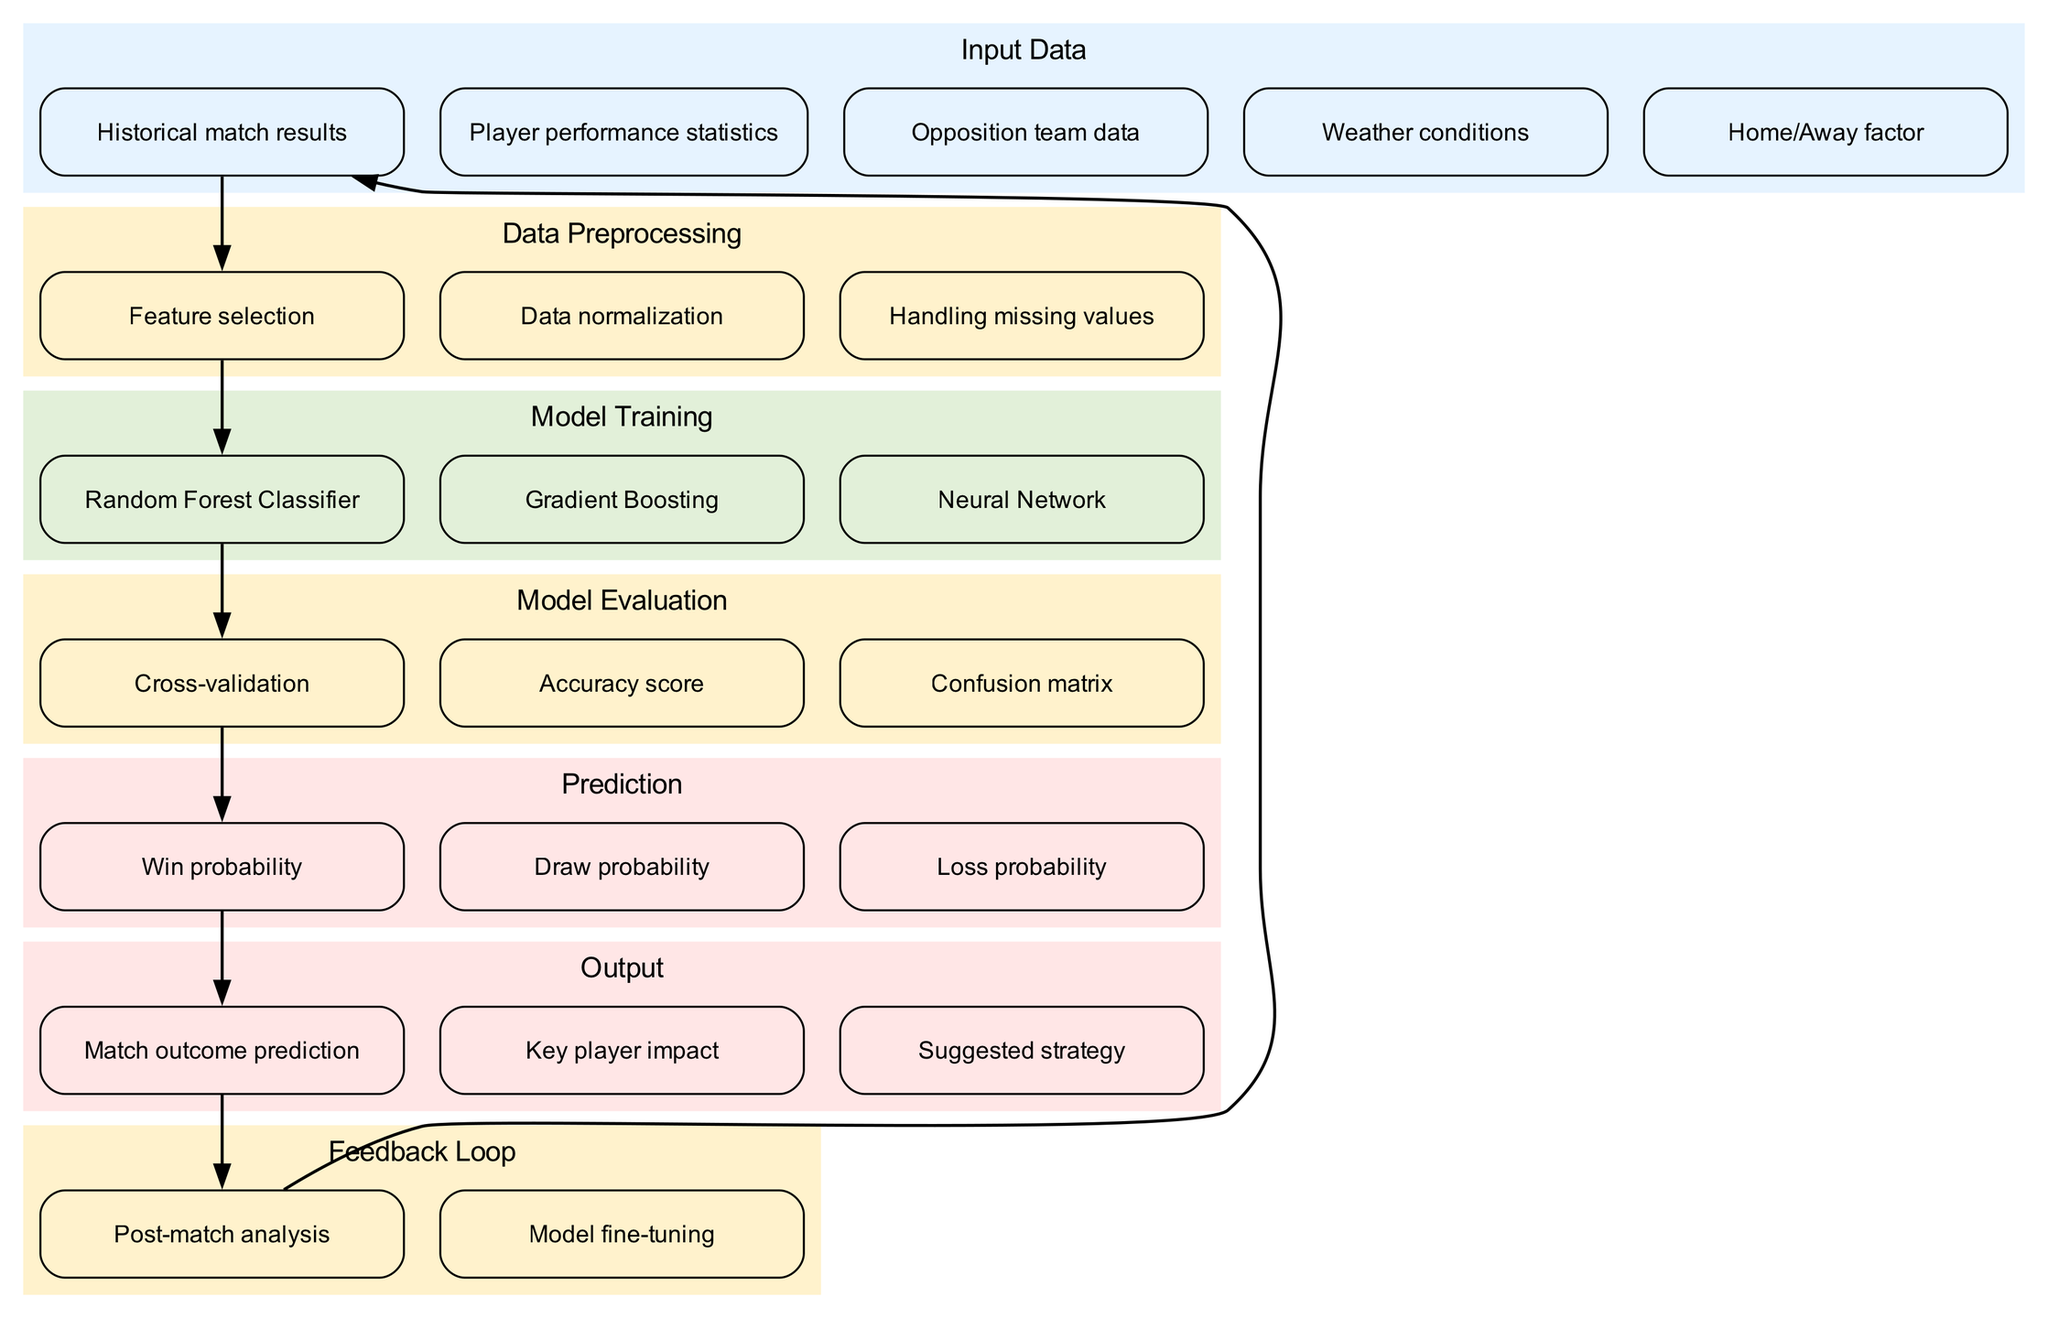What are the input data types? The diagram lists five distinct input data types: Historical match results, Player performance statistics, Opposition team data, Weather conditions, and Home/Away factor.
Answer: Historical match results, Player performance statistics, Opposition team data, Weather conditions, Home/Away factor How many model training methods are shown? The model training section of the diagram indicates three methods: Random Forest Classifier, Gradient Boosting, and Neural Network. Thus, the total count of model training methods is three.
Answer: Three Which model evaluation technique is utilized first? The flow of the diagram shows that after training the Random Forest Classifier, the Cross-validation is performed next, indicating it is the first model evaluation technique applied.
Answer: Cross-validation What is the final output of the model? The last output node in the diagram states that the model outputs a "Match outcome prediction." This is the ultimate result derived from the preceding processes of prediction.
Answer: Match outcome prediction Which factors are considered in the data preprocessing phase? The data preprocessing section of the diagram includes three specific tasks: Feature selection, Data normalization, and Handling missing values, all crucial for preparing data for model training.
Answer: Feature selection, Data normalization, Handling missing values How does the feedback loop relate to the input data? The diagram demonstrates that the Post-match analysis in the feedback loop has a directed edge connecting back to Historical match results, indicating that insights from the analysis influence future historical match results in the model inputs.
Answer: Historical match results What is predicted about the match outcomes? The prediction section of the diagram indicates three specific probabilities: Win probability, Draw probability, and Loss probability, which encapsulate the different potential outcomes of a match.
Answer: Win probability, Draw probability, Loss probability Which techniques are used for model evaluation? The diagram categorically lists three techniques for model evaluation: Cross-validation, Accuracy score, and Confusion matrix, each serving to assess the performance of the machine learning models.
Answer: Cross-validation, Accuracy score, Confusion matrix What is the purpose of the feedback loop? In the diagram, the purpose of the feedback loop is to allow for Post-match analysis, leading to Model fine-tuning, thus continually improving the model's accuracy over time through iterative learning.
Answer: Post-match analysis, Model fine-tuning 